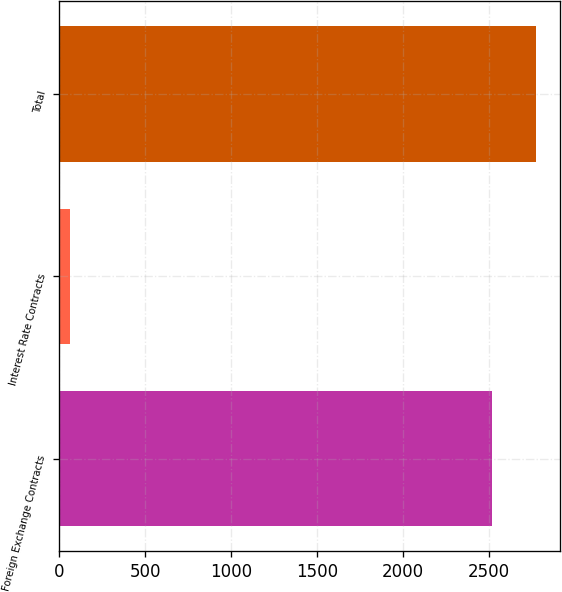Convert chart. <chart><loc_0><loc_0><loc_500><loc_500><bar_chart><fcel>Foreign Exchange Contracts<fcel>Interest Rate Contracts<fcel>Total<nl><fcel>2522.5<fcel>64.1<fcel>2774.75<nl></chart> 